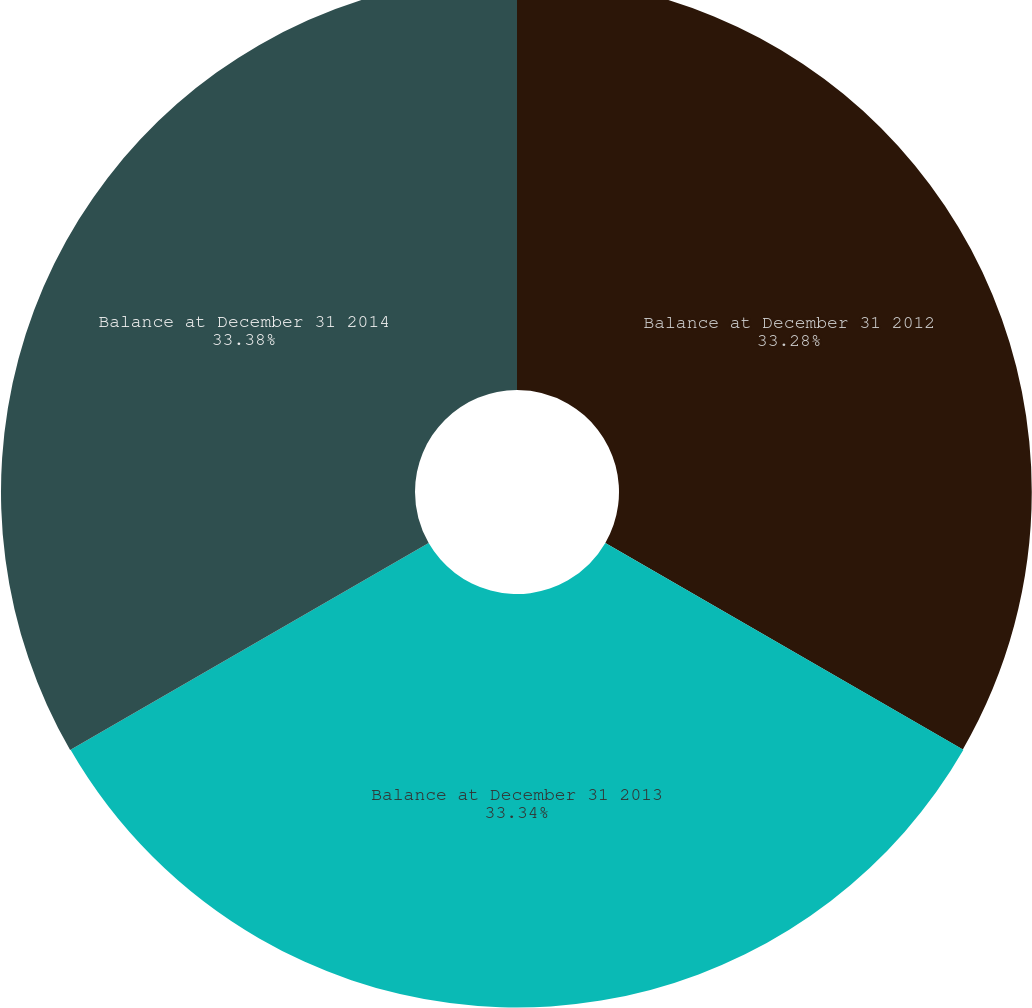<chart> <loc_0><loc_0><loc_500><loc_500><pie_chart><fcel>Balance at December 31 2012<fcel>Balance at December 31 2013<fcel>Balance at December 31 2014<nl><fcel>33.28%<fcel>33.34%<fcel>33.38%<nl></chart> 